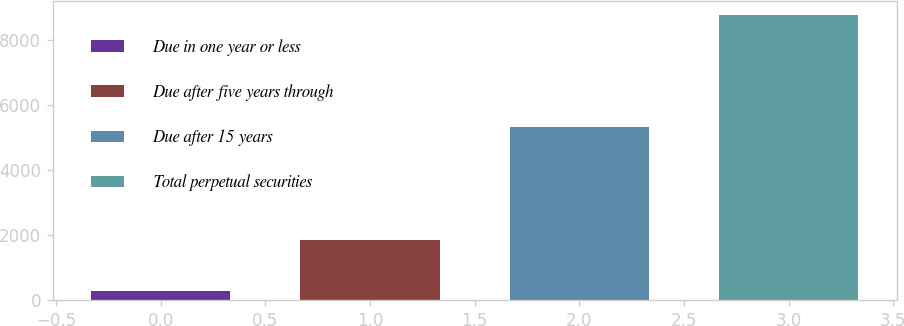Convert chart. <chart><loc_0><loc_0><loc_500><loc_500><bar_chart><fcel>Due in one year or less<fcel>Due after five years through<fcel>Due after 15 years<fcel>Total perpetual securities<nl><fcel>290<fcel>1839<fcel>5320<fcel>8760<nl></chart> 